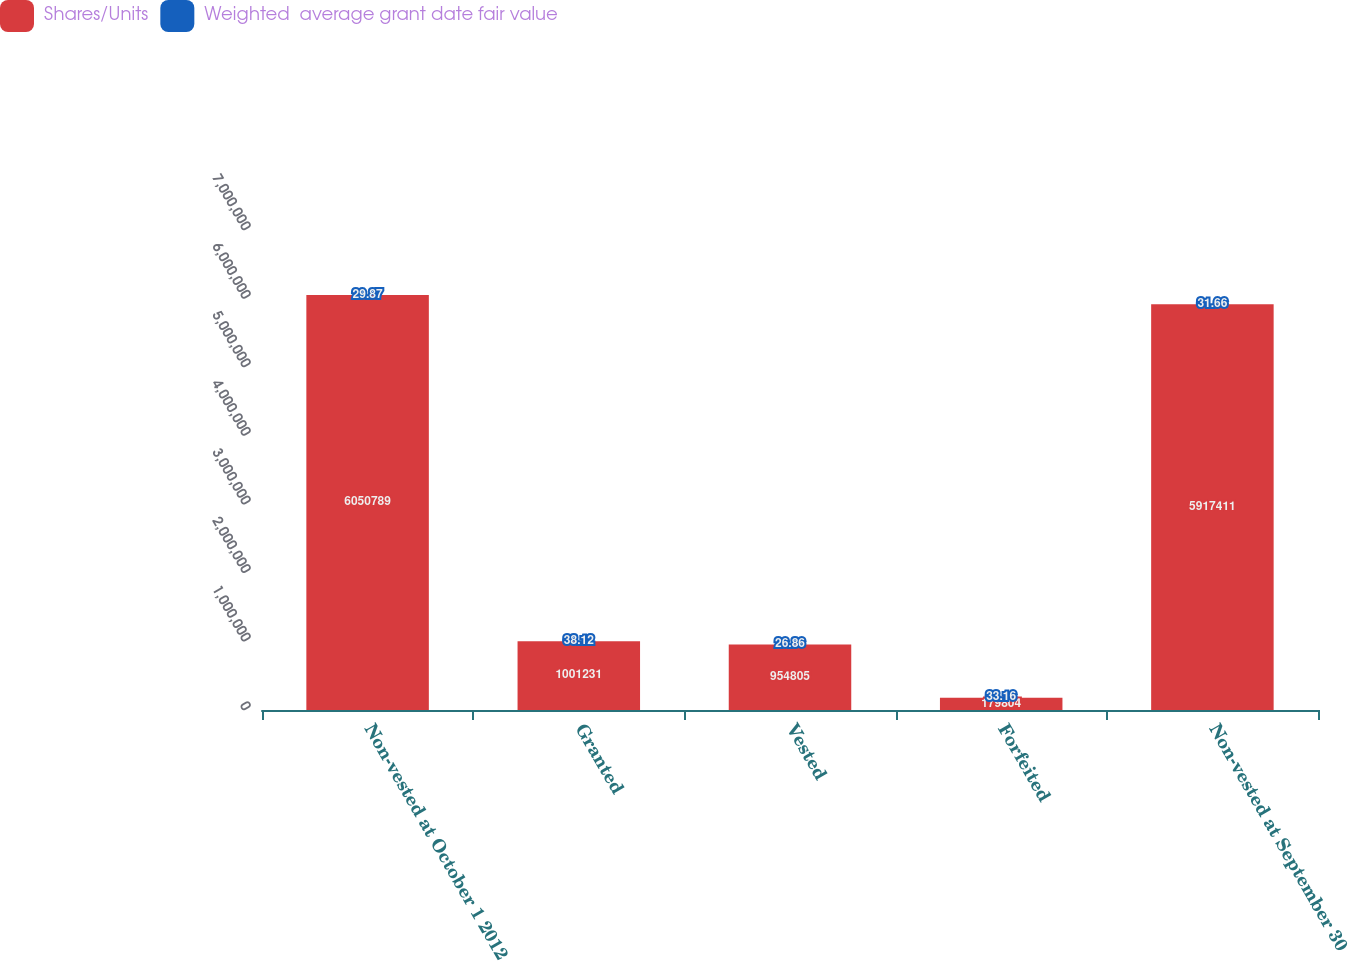<chart> <loc_0><loc_0><loc_500><loc_500><stacked_bar_chart><ecel><fcel>Non-vested at October 1 2012<fcel>Granted<fcel>Vested<fcel>Forfeited<fcel>Non-vested at September 30<nl><fcel>Shares/Units<fcel>6.05079e+06<fcel>1.00123e+06<fcel>954805<fcel>179804<fcel>5.91741e+06<nl><fcel>Weighted  average grant date fair value<fcel>29.87<fcel>38.12<fcel>26.86<fcel>33.16<fcel>31.66<nl></chart> 